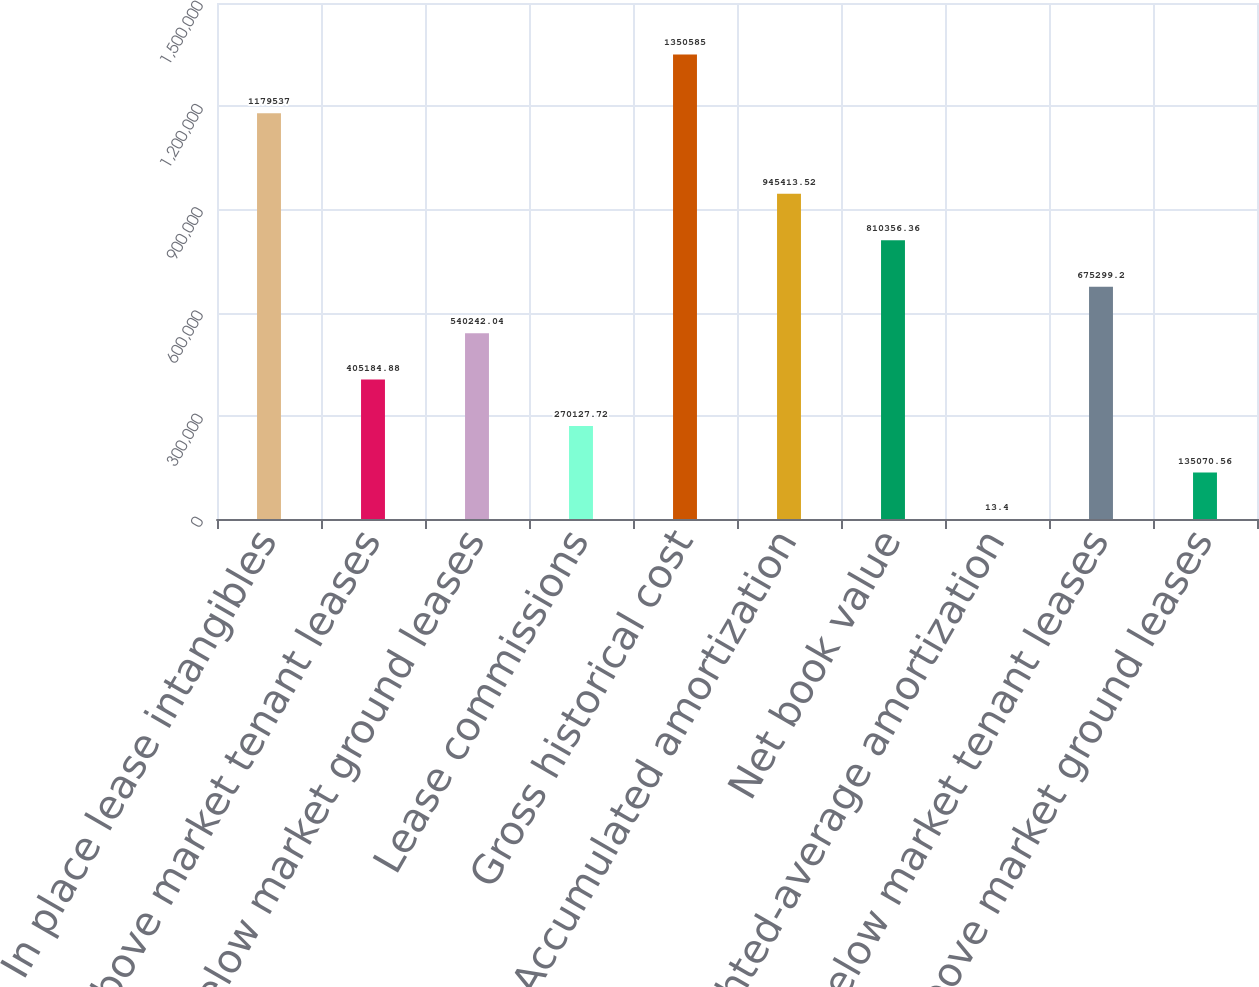Convert chart. <chart><loc_0><loc_0><loc_500><loc_500><bar_chart><fcel>In place lease intangibles<fcel>Above market tenant leases<fcel>Below market ground leases<fcel>Lease commissions<fcel>Gross historical cost<fcel>Accumulated amortization<fcel>Net book value<fcel>Weighted-average amortization<fcel>Below market tenant leases<fcel>Above market ground leases<nl><fcel>1.17954e+06<fcel>405185<fcel>540242<fcel>270128<fcel>1.35058e+06<fcel>945414<fcel>810356<fcel>13.4<fcel>675299<fcel>135071<nl></chart> 